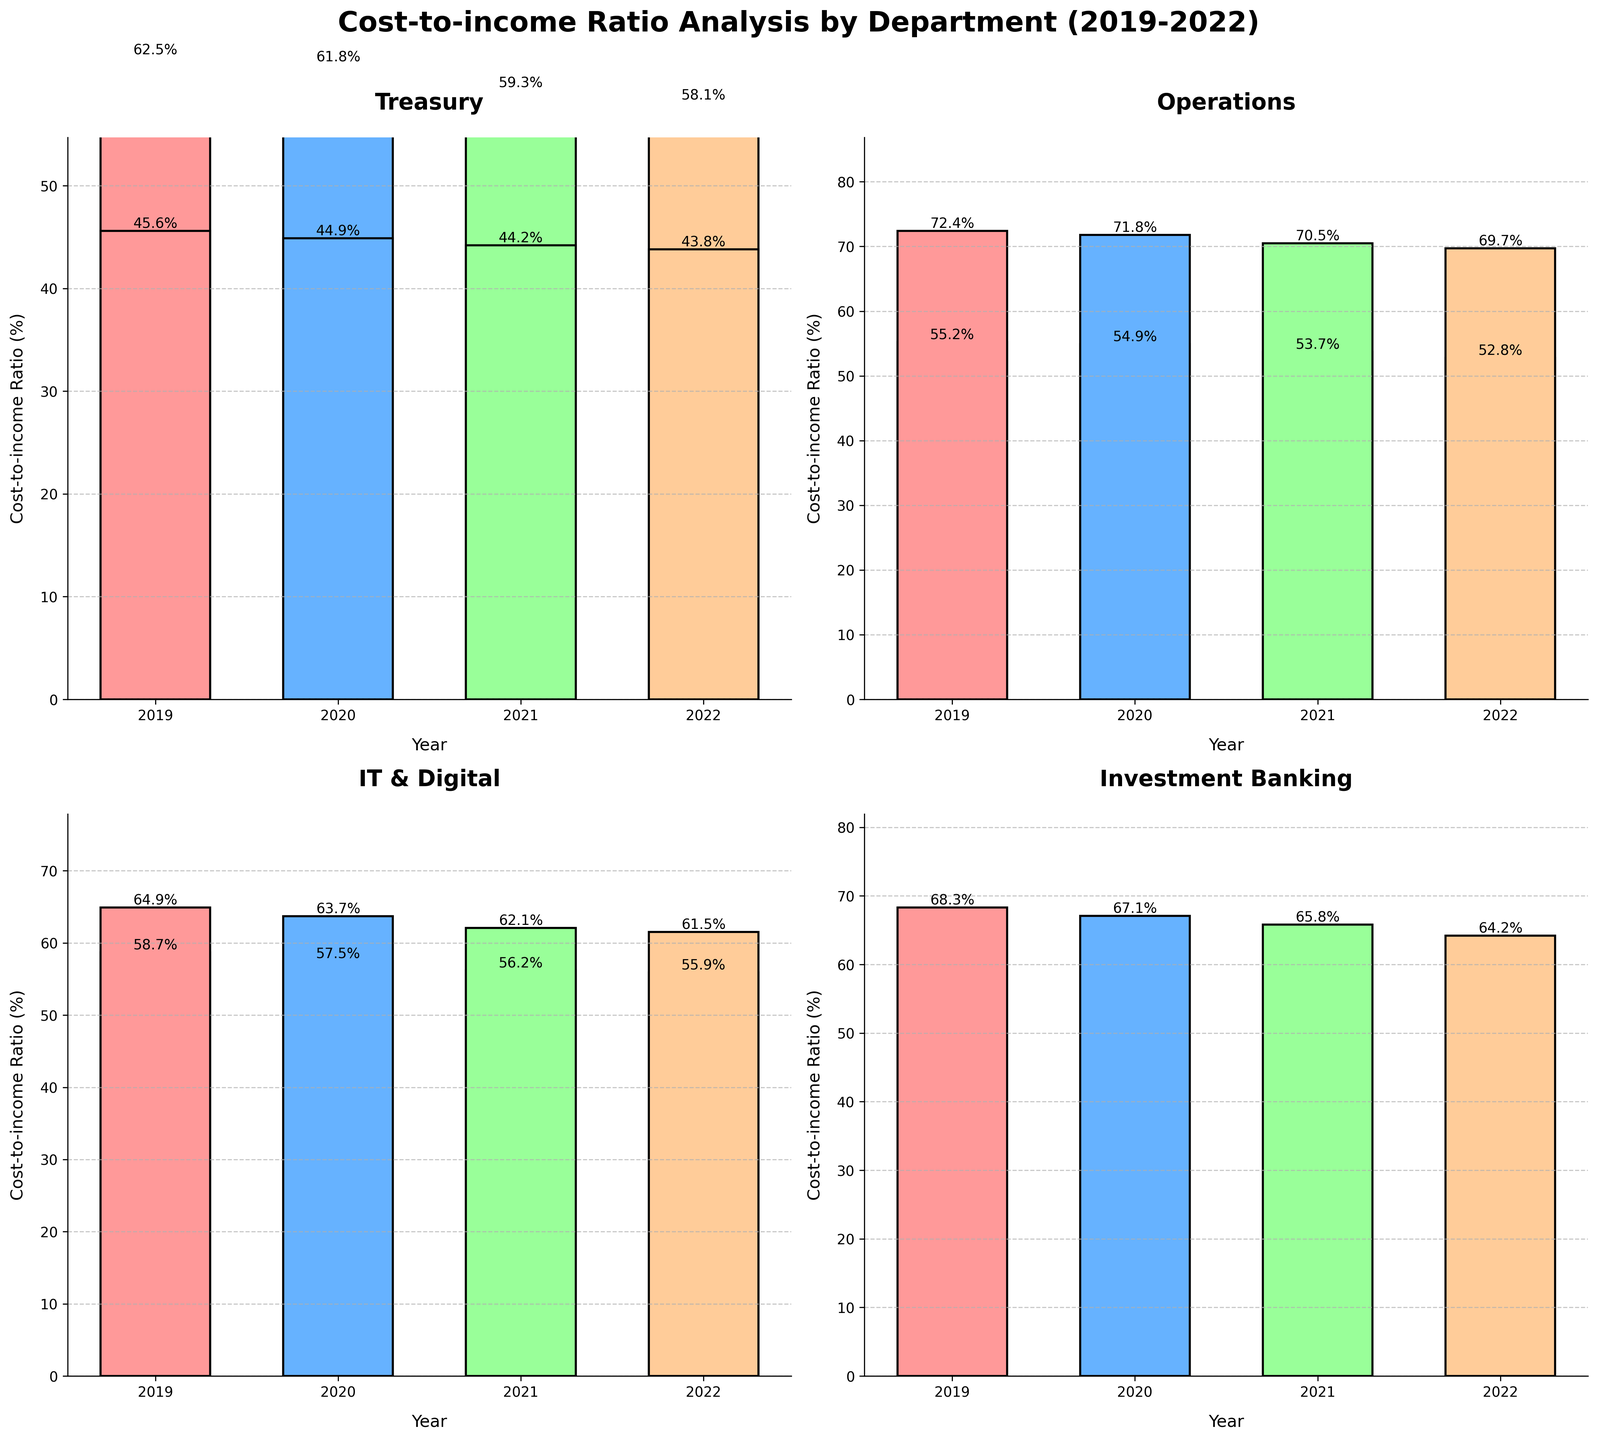What is the title of the figure? The title of the figure is located at the top center of the entire subplot. Titles often provide the main subject or purpose of the figure. In this case, it aids in quickly understanding what is being visualized.
Answer: Cost-to-income Ratio Analysis by Department (2019-2022) Which department had the highest cost-to-income ratio in 2022? To find the highest value in 2022, look at each subplot and identify the bar corresponding to 2022 (indicated by the different colors). The value of the bar will show the cost-to-income ratio.
Answer: Operations How did the cost-to-income ratio for IT & Digital change from 2019 to 2022? Look at the IT & Digital subplot, and note the height of each bar from 2019 to 2022. The height of the bars for each year shows the cost-to-income ratio for that year.
Answer: It decreased from 64.9% in 2019 to 61.5% in 2022 What is the average cost-to-income ratio of Corporate Banking over the four years? Extract the values for Corporate Banking for 2019, 2020, 2021, and 2022, then calculate the average by summing these values and dividing by the number of years.
Answer: (55.2 + 54.9 + 53.7 + 52.8)/4 = 54.15 Which department saw the largest percentage decrease in cost-to-income ratio from 2019 to 2022? For each department, compute the percentage decrease using the formula: \((\text{initial value} - \text{final value}) / \text{initial value} \times 100\). Compare the percentage decreases to find the largest one.
Answer: Investment Banking Compare the trend in cost-to-income ratios between Retail Banking and Wealth Management from 2019 to 2022. Check the trend of each bar in both the Retail Banking and Wealth Management subplots from 2019 to 2022 and note if they increased or decreased each year.
Answer: Both departments show a decreasing trend, but Retail Banking decreases more consistently What is the overall trend in the cost-to-income ratio for Treasury from 2019 to 2022? Look at the bars for Treasury from 2019 to 2022 and observe whether the ratios are increasing, decreasing, or stable over the years.
Answer: Decreasing trend By how much did the cost-to-income ratio for Operations decrease from 2019 to 2022? Subtract the 2022 value from the 2019 value for the Operations subplot.
Answer: 72.4 - 69.7 = 2.7 Between Retail Banking and IT & Digital, which had a greater decrease in the cost-to-income ratio between 2019 to 2022? Calculate the decrease for both departments by subtracting the 2022 value from the 2019 value for each department and compare the results.
Answer: IT & Digital Which department has the lowest cost-to-income ratio in 2021? Find the bar representing 2021 for each subplot and identify the shortest bar, which indicates the lowest cost-to-income ratio for that year.
Answer: Treasury 